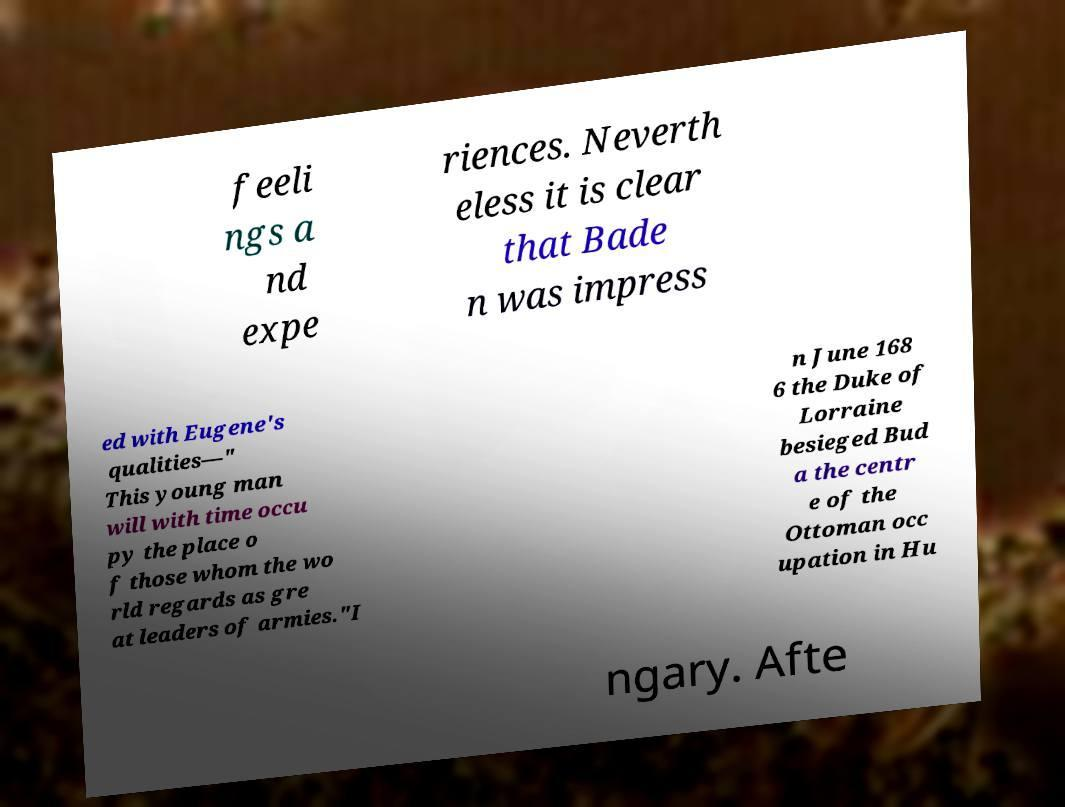Can you read and provide the text displayed in the image?This photo seems to have some interesting text. Can you extract and type it out for me? feeli ngs a nd expe riences. Neverth eless it is clear that Bade n was impress ed with Eugene's qualities—" This young man will with time occu py the place o f those whom the wo rld regards as gre at leaders of armies."I n June 168 6 the Duke of Lorraine besieged Bud a the centr e of the Ottoman occ upation in Hu ngary. Afte 